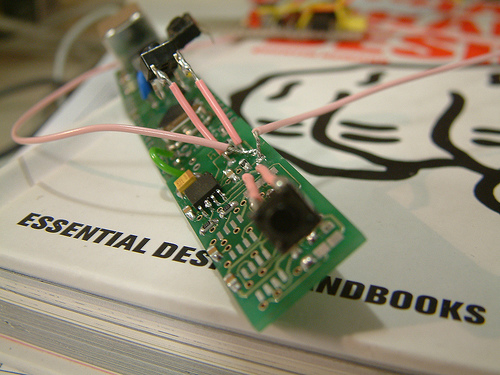<image>
Is there a circuit chip next to the note book? No. The circuit chip is not positioned next to the note book. They are located in different areas of the scene. 